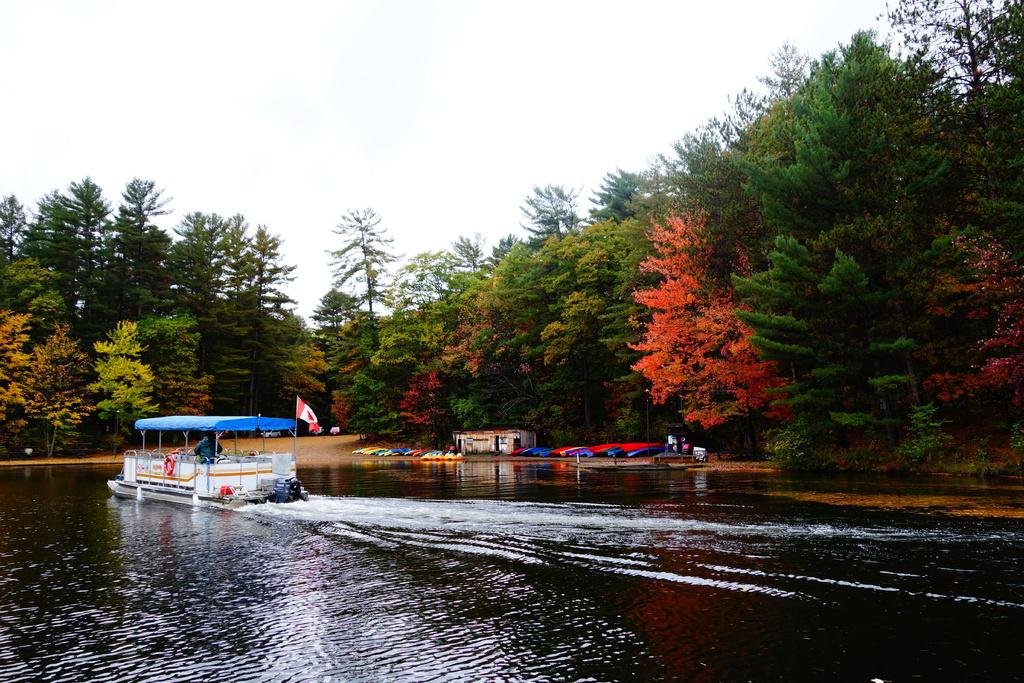What is located on the left side of the image? There is a boat on the water on the left side of the image. What can be seen in the background of the image? There are trees, a house, and other unspecified objects visible in the background of the image. What is the purpose of the flag in the image? The purpose of the flag in the image is not specified, but it may indicate a location or represent a group or organization. What type of root can be seen growing from the boat in the image? There is no root growing from the boat in the image; it is a boat on the water. What color is the pencil used to draw the house in the background of the image? There is no pencil or drawing present in the image; it is a photograph or illustration of a real house. 